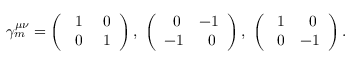<formula> <loc_0><loc_0><loc_500><loc_500>\gamma _ { m } ^ { \mu \nu } = \left ( \begin{array} { c c } { 1 } & { 0 } \\ { 0 } & { 1 } \end{array} \right ) , \left ( \begin{array} { c c } { 0 } & { - 1 } \\ { - 1 } & { 0 } \end{array} \right ) , \left ( \begin{array} { c c } { 1 } & { 0 } \\ { 0 } & { - 1 } \end{array} \right ) .</formula> 